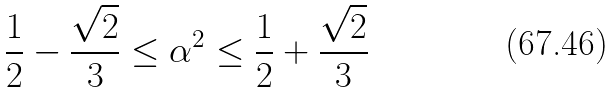Convert formula to latex. <formula><loc_0><loc_0><loc_500><loc_500>\frac { 1 } { 2 } - \frac { \sqrt { 2 } } { 3 } \leq \alpha ^ { 2 } \leq \frac { 1 } { 2 } + \frac { \sqrt { 2 } } { 3 }</formula> 